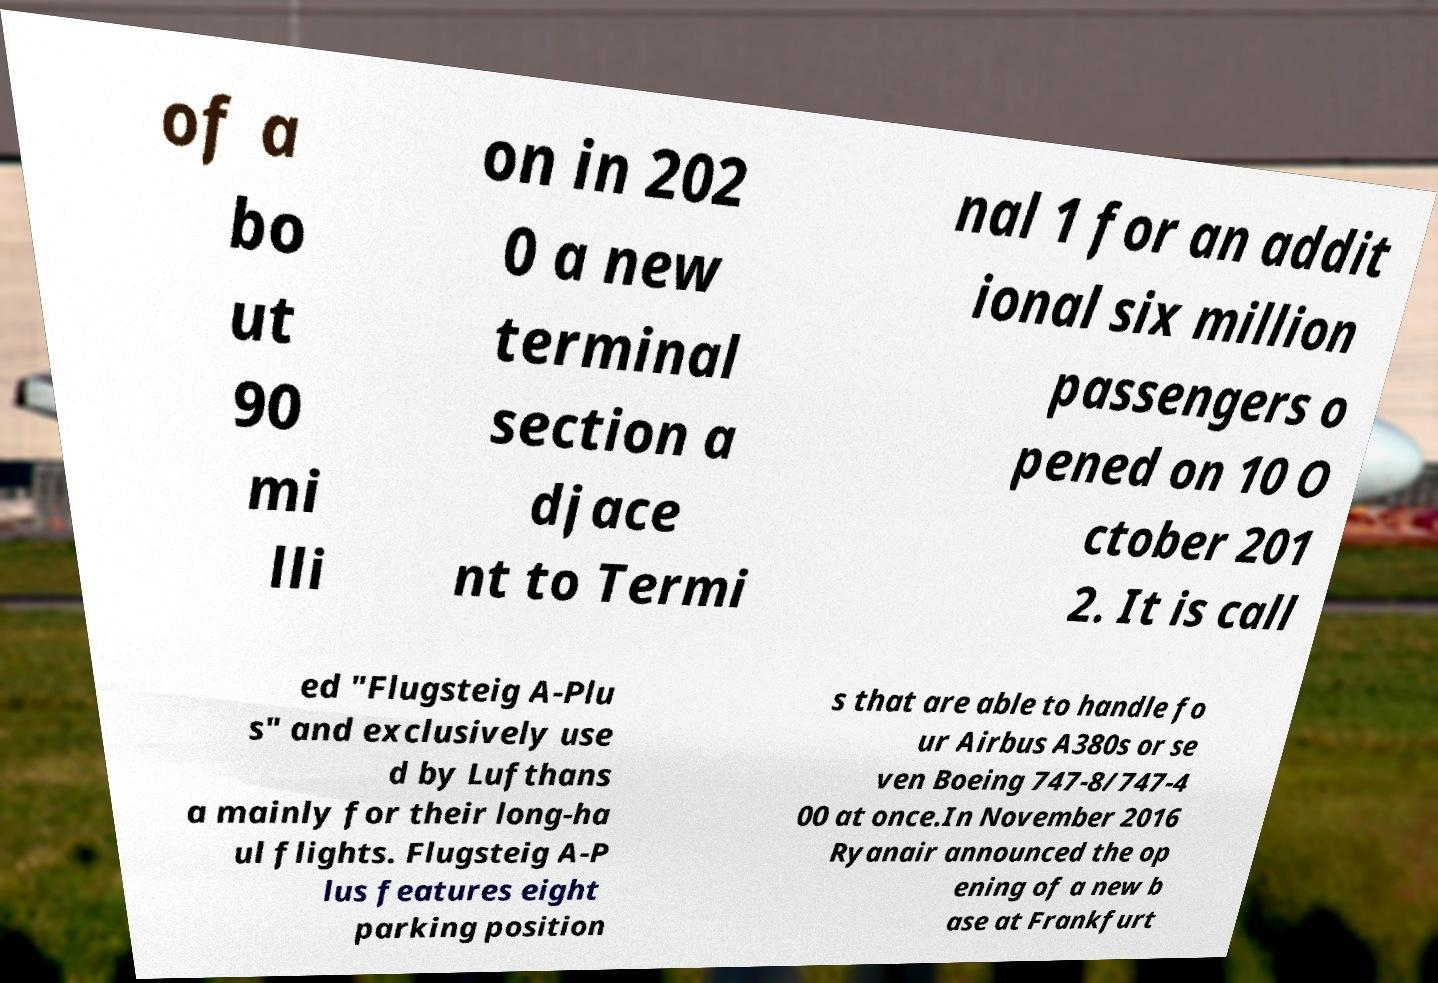Please read and relay the text visible in this image. What does it say? of a bo ut 90 mi lli on in 202 0 a new terminal section a djace nt to Termi nal 1 for an addit ional six million passengers o pened on 10 O ctober 201 2. It is call ed "Flugsteig A-Plu s" and exclusively use d by Lufthans a mainly for their long-ha ul flights. Flugsteig A-P lus features eight parking position s that are able to handle fo ur Airbus A380s or se ven Boeing 747-8/747-4 00 at once.In November 2016 Ryanair announced the op ening of a new b ase at Frankfurt 